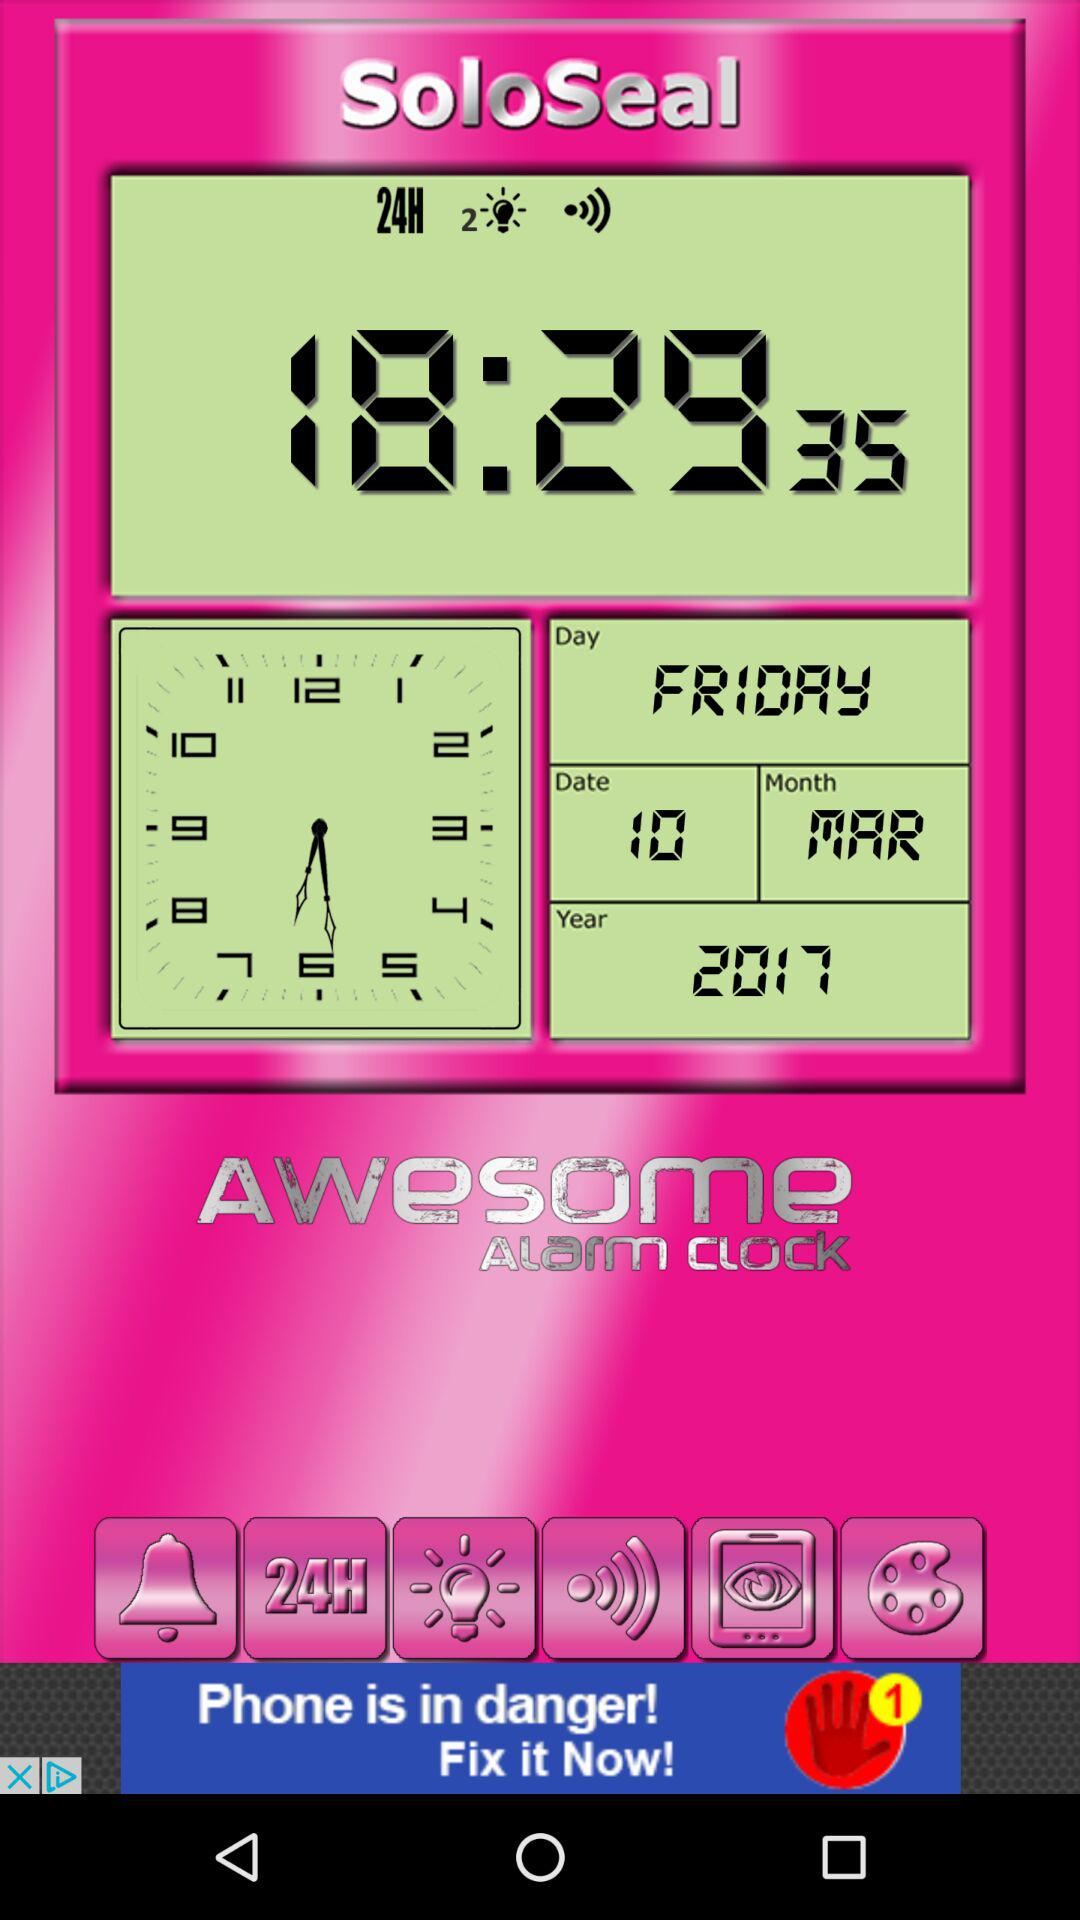What is the displayed time? The displayed time is 18:29:35. 